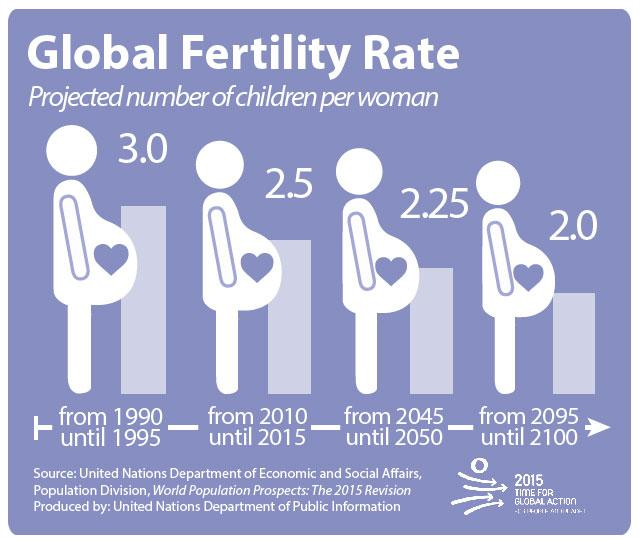Identify some key points in this picture. The global fertility rate from 2010 until 2015 was 2.5. 